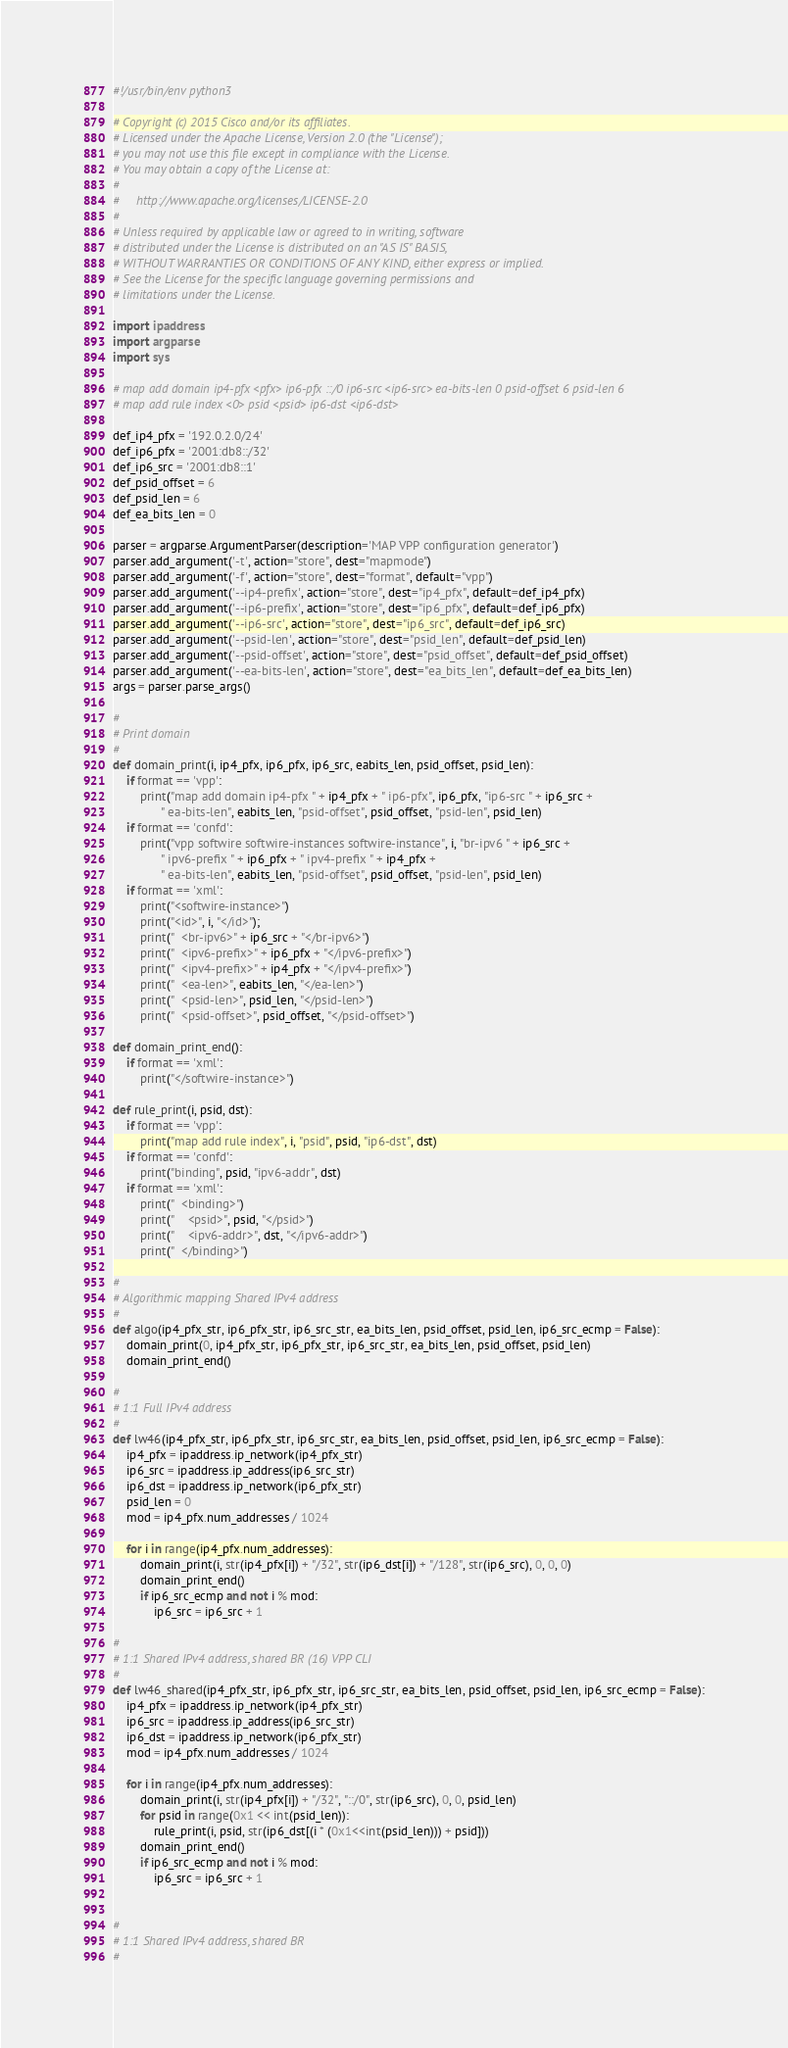Convert code to text. <code><loc_0><loc_0><loc_500><loc_500><_Python_>#!/usr/bin/env python3

# Copyright (c) 2015 Cisco and/or its affiliates.
# Licensed under the Apache License, Version 2.0 (the "License");
# you may not use this file except in compliance with the License.
# You may obtain a copy of the License at:
#
#     http://www.apache.org/licenses/LICENSE-2.0
#
# Unless required by applicable law or agreed to in writing, software
# distributed under the License is distributed on an "AS IS" BASIS,
# WITHOUT WARRANTIES OR CONDITIONS OF ANY KIND, either express or implied.
# See the License for the specific language governing permissions and
# limitations under the License.

import ipaddress
import argparse
import sys

# map add domain ip4-pfx <pfx> ip6-pfx ::/0 ip6-src <ip6-src> ea-bits-len 0 psid-offset 6 psid-len 6
# map add rule index <0> psid <psid> ip6-dst <ip6-dst>

def_ip4_pfx = '192.0.2.0/24'
def_ip6_pfx = '2001:db8::/32'
def_ip6_src = '2001:db8::1'
def_psid_offset = 6
def_psid_len = 6
def_ea_bits_len = 0

parser = argparse.ArgumentParser(description='MAP VPP configuration generator')
parser.add_argument('-t', action="store", dest="mapmode")
parser.add_argument('-f', action="store", dest="format", default="vpp")
parser.add_argument('--ip4-prefix', action="store", dest="ip4_pfx", default=def_ip4_pfx)
parser.add_argument('--ip6-prefix', action="store", dest="ip6_pfx", default=def_ip6_pfx)
parser.add_argument('--ip6-src', action="store", dest="ip6_src", default=def_ip6_src)
parser.add_argument('--psid-len', action="store", dest="psid_len", default=def_psid_len)
parser.add_argument('--psid-offset', action="store", dest="psid_offset", default=def_psid_offset)
parser.add_argument('--ea-bits-len', action="store", dest="ea_bits_len", default=def_ea_bits_len)
args = parser.parse_args()

#
# Print domain
#
def domain_print(i, ip4_pfx, ip6_pfx, ip6_src, eabits_len, psid_offset, psid_len):
    if format == 'vpp':
        print("map add domain ip4-pfx " + ip4_pfx + " ip6-pfx", ip6_pfx, "ip6-src " + ip6_src +
              " ea-bits-len", eabits_len, "psid-offset", psid_offset, "psid-len", psid_len)
    if format == 'confd':
        print("vpp softwire softwire-instances softwire-instance", i, "br-ipv6 " + ip6_src +
              " ipv6-prefix " + ip6_pfx + " ipv4-prefix " + ip4_pfx +
              " ea-bits-len", eabits_len, "psid-offset", psid_offset, "psid-len", psid_len)
    if format == 'xml':
        print("<softwire-instance>")
        print("<id>", i, "</id>");
        print("  <br-ipv6>" + ip6_src + "</br-ipv6>")
        print("  <ipv6-prefix>" + ip6_pfx + "</ipv6-prefix>")
        print("  <ipv4-prefix>" + ip4_pfx + "</ipv4-prefix>")
        print("  <ea-len>", eabits_len, "</ea-len>")
        print("  <psid-len>", psid_len, "</psid-len>")
        print("  <psid-offset>", psid_offset, "</psid-offset>")

def domain_print_end():
    if format == 'xml':
        print("</softwire-instance>")

def rule_print(i, psid, dst):
    if format == 'vpp':
        print("map add rule index", i, "psid", psid, "ip6-dst", dst)
    if format == 'confd':
        print("binding", psid, "ipv6-addr", dst)
    if format == 'xml':
        print("  <binding>")
        print("    <psid>", psid, "</psid>")
        print("    <ipv6-addr>", dst, "</ipv6-addr>")
        print("  </binding>")

#
# Algorithmic mapping Shared IPv4 address
#
def algo(ip4_pfx_str, ip6_pfx_str, ip6_src_str, ea_bits_len, psid_offset, psid_len, ip6_src_ecmp = False):
    domain_print(0, ip4_pfx_str, ip6_pfx_str, ip6_src_str, ea_bits_len, psid_offset, psid_len)
    domain_print_end()

#
# 1:1 Full IPv4 address
#
def lw46(ip4_pfx_str, ip6_pfx_str, ip6_src_str, ea_bits_len, psid_offset, psid_len, ip6_src_ecmp = False):
    ip4_pfx = ipaddress.ip_network(ip4_pfx_str)
    ip6_src = ipaddress.ip_address(ip6_src_str)
    ip6_dst = ipaddress.ip_network(ip6_pfx_str)
    psid_len = 0
    mod = ip4_pfx.num_addresses / 1024

    for i in range(ip4_pfx.num_addresses):
        domain_print(i, str(ip4_pfx[i]) + "/32", str(ip6_dst[i]) + "/128", str(ip6_src), 0, 0, 0)
        domain_print_end()
        if ip6_src_ecmp and not i % mod:
            ip6_src = ip6_src + 1

#
# 1:1 Shared IPv4 address, shared BR (16) VPP CLI
#
def lw46_shared(ip4_pfx_str, ip6_pfx_str, ip6_src_str, ea_bits_len, psid_offset, psid_len, ip6_src_ecmp = False):
    ip4_pfx = ipaddress.ip_network(ip4_pfx_str)
    ip6_src = ipaddress.ip_address(ip6_src_str)
    ip6_dst = ipaddress.ip_network(ip6_pfx_str)
    mod = ip4_pfx.num_addresses / 1024

    for i in range(ip4_pfx.num_addresses):
        domain_print(i, str(ip4_pfx[i]) + "/32", "::/0", str(ip6_src), 0, 0, psid_len)
        for psid in range(0x1 << int(psid_len)):
            rule_print(i, psid, str(ip6_dst[(i * (0x1<<int(psid_len))) + psid]))
        domain_print_end()
        if ip6_src_ecmp and not i % mod:
            ip6_src = ip6_src + 1


#
# 1:1 Shared IPv4 address, shared BR
#</code> 